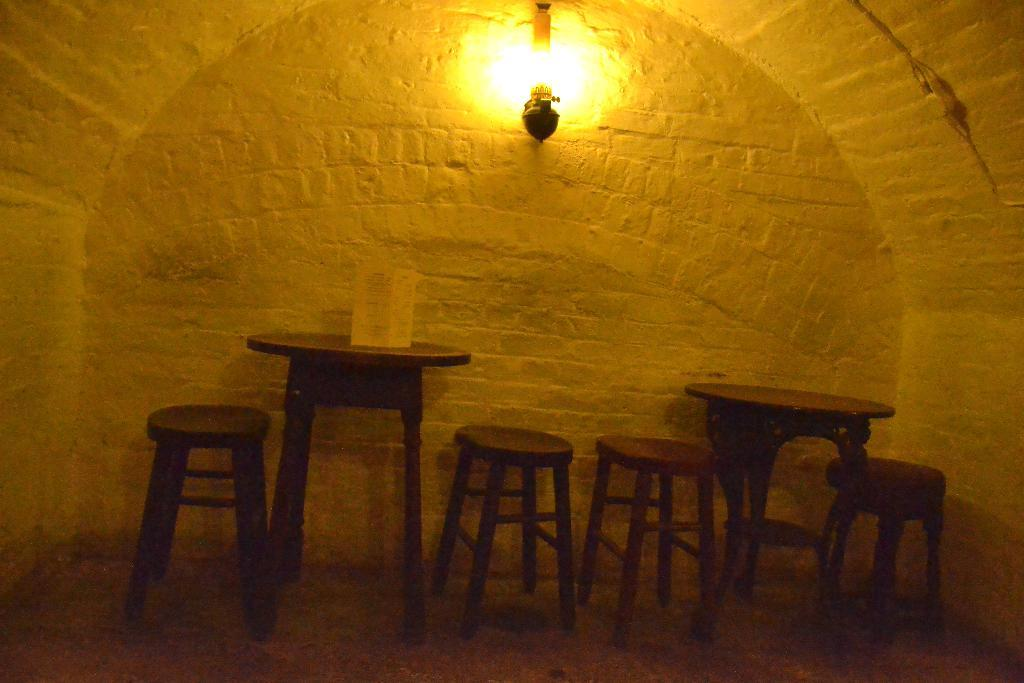What type of furniture is present in the image? There are tables in the image. What is placed on one of the tables? There is a placard on one of the tables. Can you describe any other objects or features in the image? There is a light on the wall in the image. How many babies are crawling on the tables in the image? There are no babies present in the image; it only features tables, a placard, and a light on the wall. 